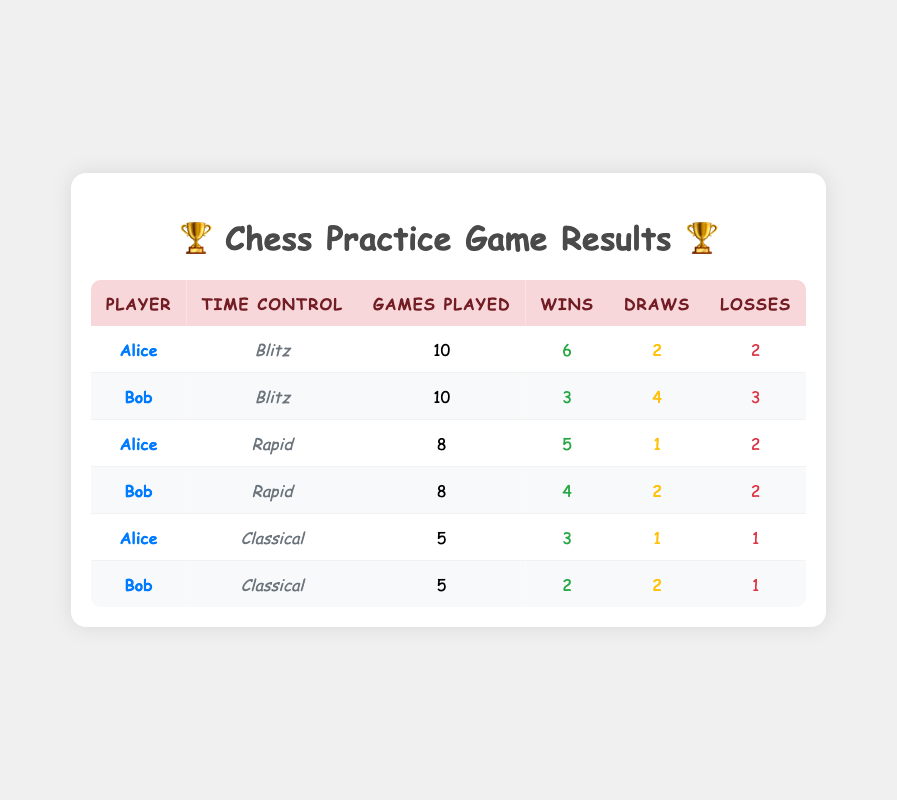What is the total number of games played by Bob in all time controls? Bob has played in three time controls: Blitz (10 games), Rapid (8 games), and Classical (5 games). To find the total number of games, we sum these: 10 + 8 + 5 = 23 games.
Answer: 23 Who won more games, Alice or Bob, in the Blitz time control? In the Blitz time control, Alice won 6 games while Bob won 3 games. Since 6 is greater than 3, Alice won more games than Bob in Blitz.
Answer: Alice What is the average number of draws per game for Alice across all time controls? Alice's total draws are from Blitz (2), Rapid (1), and Classical (1), which gives a total of 2 + 1 + 1 = 4 draws. She played a total of 10 (Blitz) + 8 (Rapid) + 5 (Classical) = 23 games. The average is 4 draws / 23 games ≈ 0.17.
Answer: 0.17 Did both players win the same number of games in the Classical time control? In the Classical time control, Alice won 3 games and Bob won 2 games. Since 3 is not equal to 2, they did not win the same number of games.
Answer: No What is the difference in the number of losses between Alice and Bob in the Rapid time control? In the Rapid time control, Alice had 2 losses and Bob also had 2 losses. The difference is calculated as 2 - 2 = 0 losses.
Answer: 0 